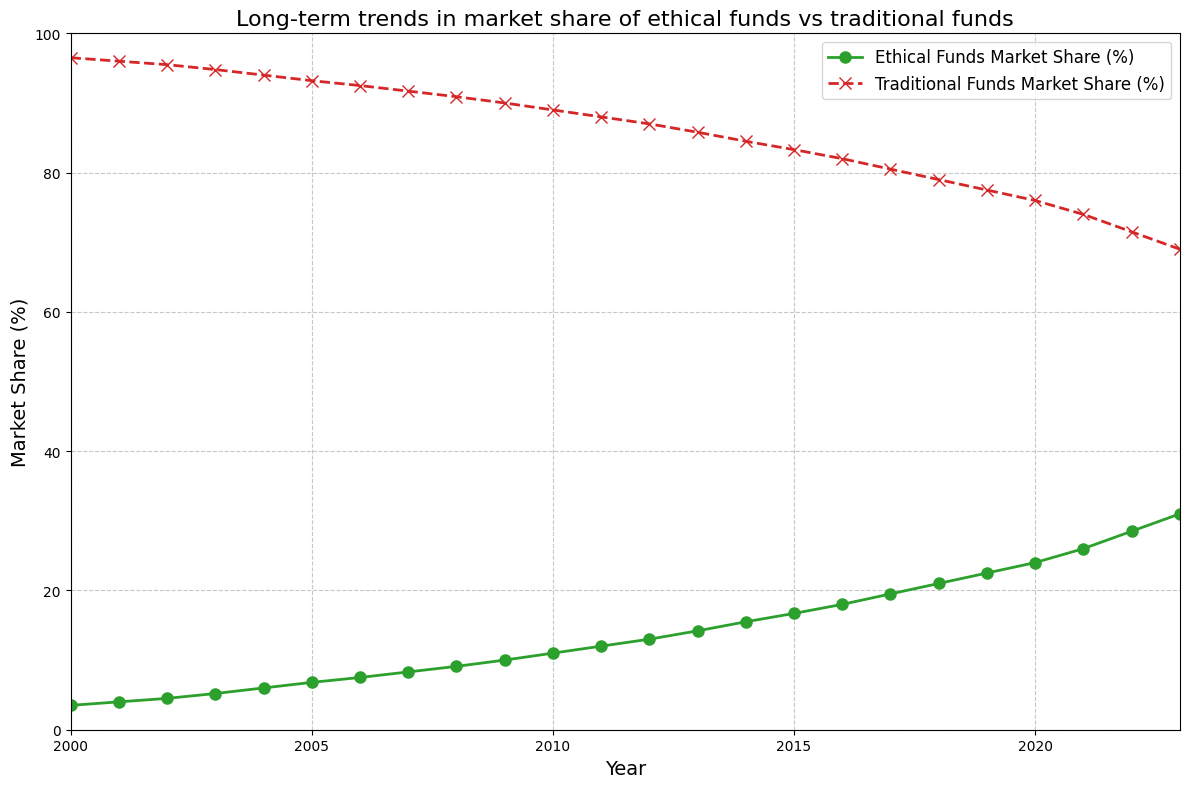What's the market share of ethical funds in 2020? In the year 2020, the figure shows that the market share of ethical funds is at the 24% mark.
Answer: 24% How much did the market share of traditional funds decrease from 2000 to 2023? The market share of traditional funds in 2000 was 96.5%, and in 2023 it was 69%. The decrease would be 96.5% - 69%.
Answer: 27.5% In which year did ethical funds first exceed a 20% market share? By examining the trendline for ethical funds, it is evident that ethical funds first exceeded a 20% market share in 2018.
Answer: 2018 What is the combined market share of ethical and traditional funds in 2005? In 2005, the market share of ethical funds was 6.8%, and traditional funds were 93.2%. Their combined market share is 6.8% + 93.2%.
Answer: 100% Which color represents the trend of ethical funds in the plot? Ethical funds are represented by the green line in the plot.
Answer: Green By how much did the market share of ethical funds grow between 2015 and 2020? The market share of ethical funds in 2015 was 16.7% and in 2020 it was 24%. The growth would be 24% - 16.7%.
Answer: 7.3% Is there any year when the market share of both funds increased or decreased together? By observing the trends, there is no year where the market share of both ethical and traditional funds increases or decreases together; the growth in one corresponds to a drop in the other.
Answer: No What is the difference in market share between ethical funds and traditional funds in 2023? In 2023, the market share for ethical funds is 31% and for traditional funds is 69%. The difference is 69% - 31%.
Answer: 38% What's the average annual increase in the market share of ethical funds from 2000 to 2023? To find the average annual increase, first find the total increase from 2000 (3.5%) to 2023 (31%), which is 31% - 3.5% = 27.5%. Then divide by the number of years, which is 2023 - 2000 = 23 years.
Answer: 1.2% In which year did the market share of ethical funds reach double digits for the first time? Ethical funds reached a double-digit market share for the first time in 2009, as the value was 10%.
Answer: 2009 